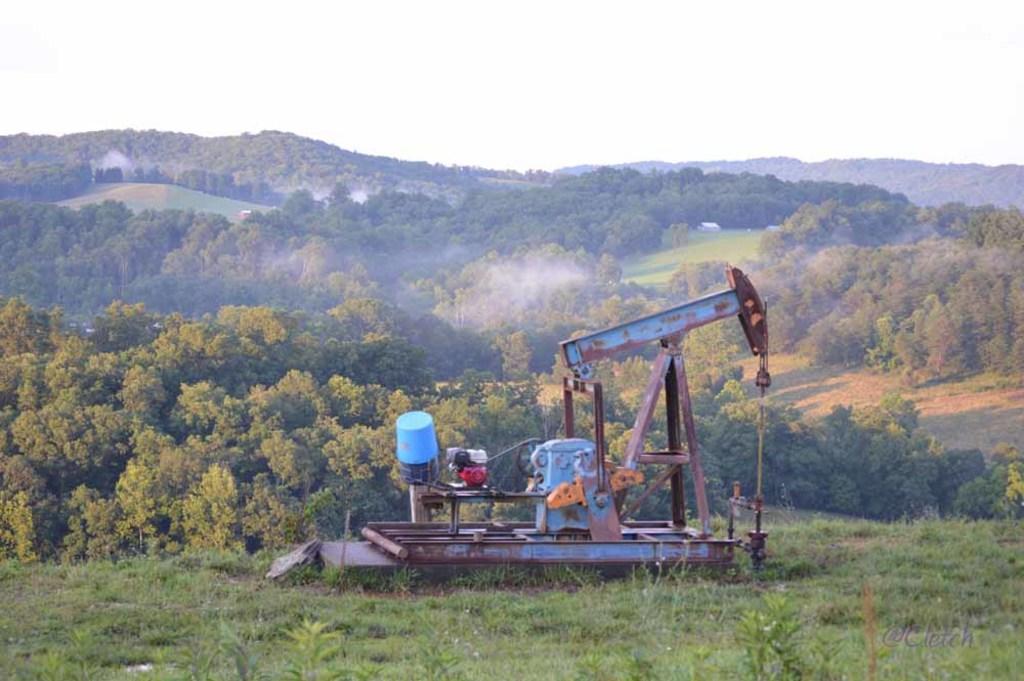In one or two sentences, can you explain what this image depicts? There is a machine with iron rods. On the ground there are plants. In the background there are trees and sky. Also there is a watermark in the right bottom corner. 